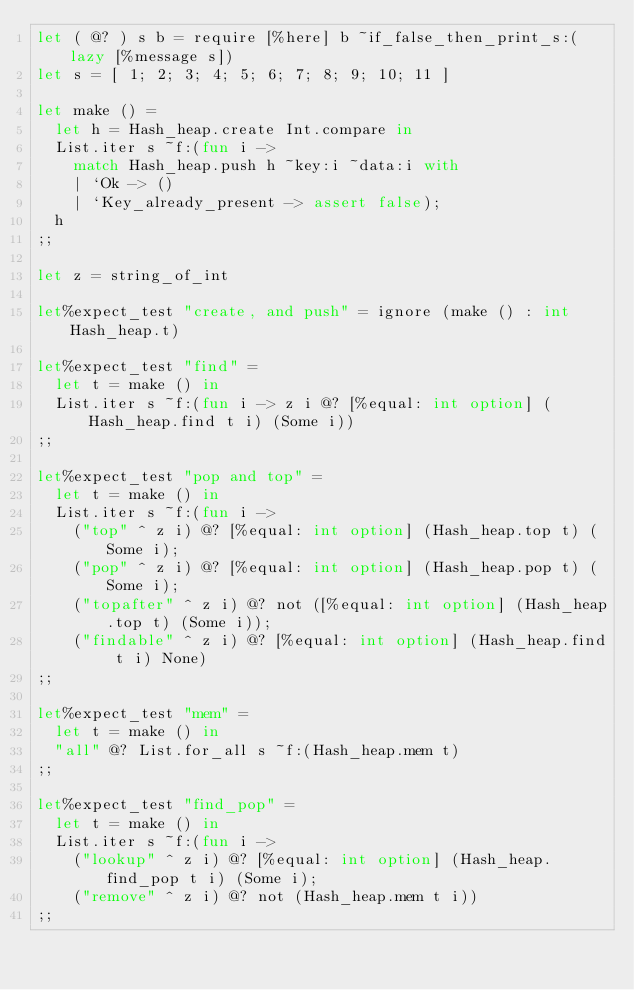<code> <loc_0><loc_0><loc_500><loc_500><_OCaml_>let ( @? ) s b = require [%here] b ~if_false_then_print_s:(lazy [%message s])
let s = [ 1; 2; 3; 4; 5; 6; 7; 8; 9; 10; 11 ]

let make () =
  let h = Hash_heap.create Int.compare in
  List.iter s ~f:(fun i ->
    match Hash_heap.push h ~key:i ~data:i with
    | `Ok -> ()
    | `Key_already_present -> assert false);
  h
;;

let z = string_of_int

let%expect_test "create, and push" = ignore (make () : int Hash_heap.t)

let%expect_test "find" =
  let t = make () in
  List.iter s ~f:(fun i -> z i @? [%equal: int option] (Hash_heap.find t i) (Some i))
;;

let%expect_test "pop and top" =
  let t = make () in
  List.iter s ~f:(fun i ->
    ("top" ^ z i) @? [%equal: int option] (Hash_heap.top t) (Some i);
    ("pop" ^ z i) @? [%equal: int option] (Hash_heap.pop t) (Some i);
    ("topafter" ^ z i) @? not ([%equal: int option] (Hash_heap.top t) (Some i));
    ("findable" ^ z i) @? [%equal: int option] (Hash_heap.find t i) None)
;;

let%expect_test "mem" =
  let t = make () in
  "all" @? List.for_all s ~f:(Hash_heap.mem t)
;;

let%expect_test "find_pop" =
  let t = make () in
  List.iter s ~f:(fun i ->
    ("lookup" ^ z i) @? [%equal: int option] (Hash_heap.find_pop t i) (Some i);
    ("remove" ^ z i) @? not (Hash_heap.mem t i))
;;
</code> 